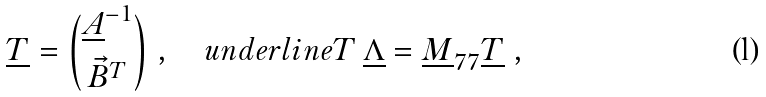<formula> <loc_0><loc_0><loc_500><loc_500>\underline { T } = { \underline { A } ^ { - 1 } \choose { \vec { B } } ^ { T } } \ , \quad u n d e r l i n e T \, \underline { \Lambda } = \underline { M } _ { 7 7 } \underline { T } \ ,</formula> 